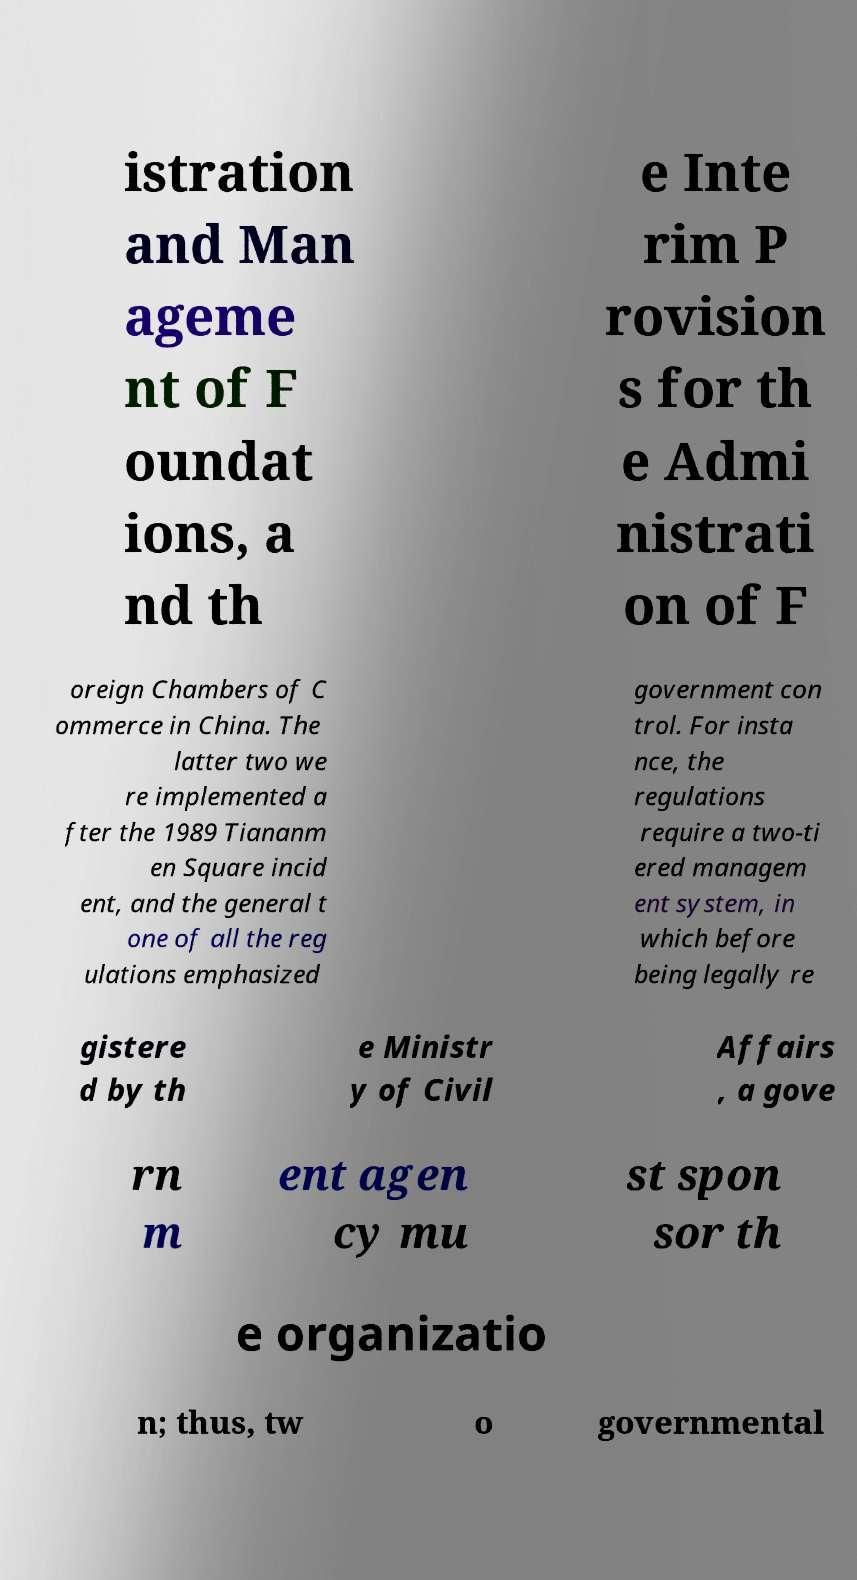For documentation purposes, I need the text within this image transcribed. Could you provide that? istration and Man ageme nt of F oundat ions, a nd th e Inte rim P rovision s for th e Admi nistrati on of F oreign Chambers of C ommerce in China. The latter two we re implemented a fter the 1989 Tiananm en Square incid ent, and the general t one of all the reg ulations emphasized government con trol. For insta nce, the regulations require a two-ti ered managem ent system, in which before being legally re gistere d by th e Ministr y of Civil Affairs , a gove rn m ent agen cy mu st spon sor th e organizatio n; thus, tw o governmental 